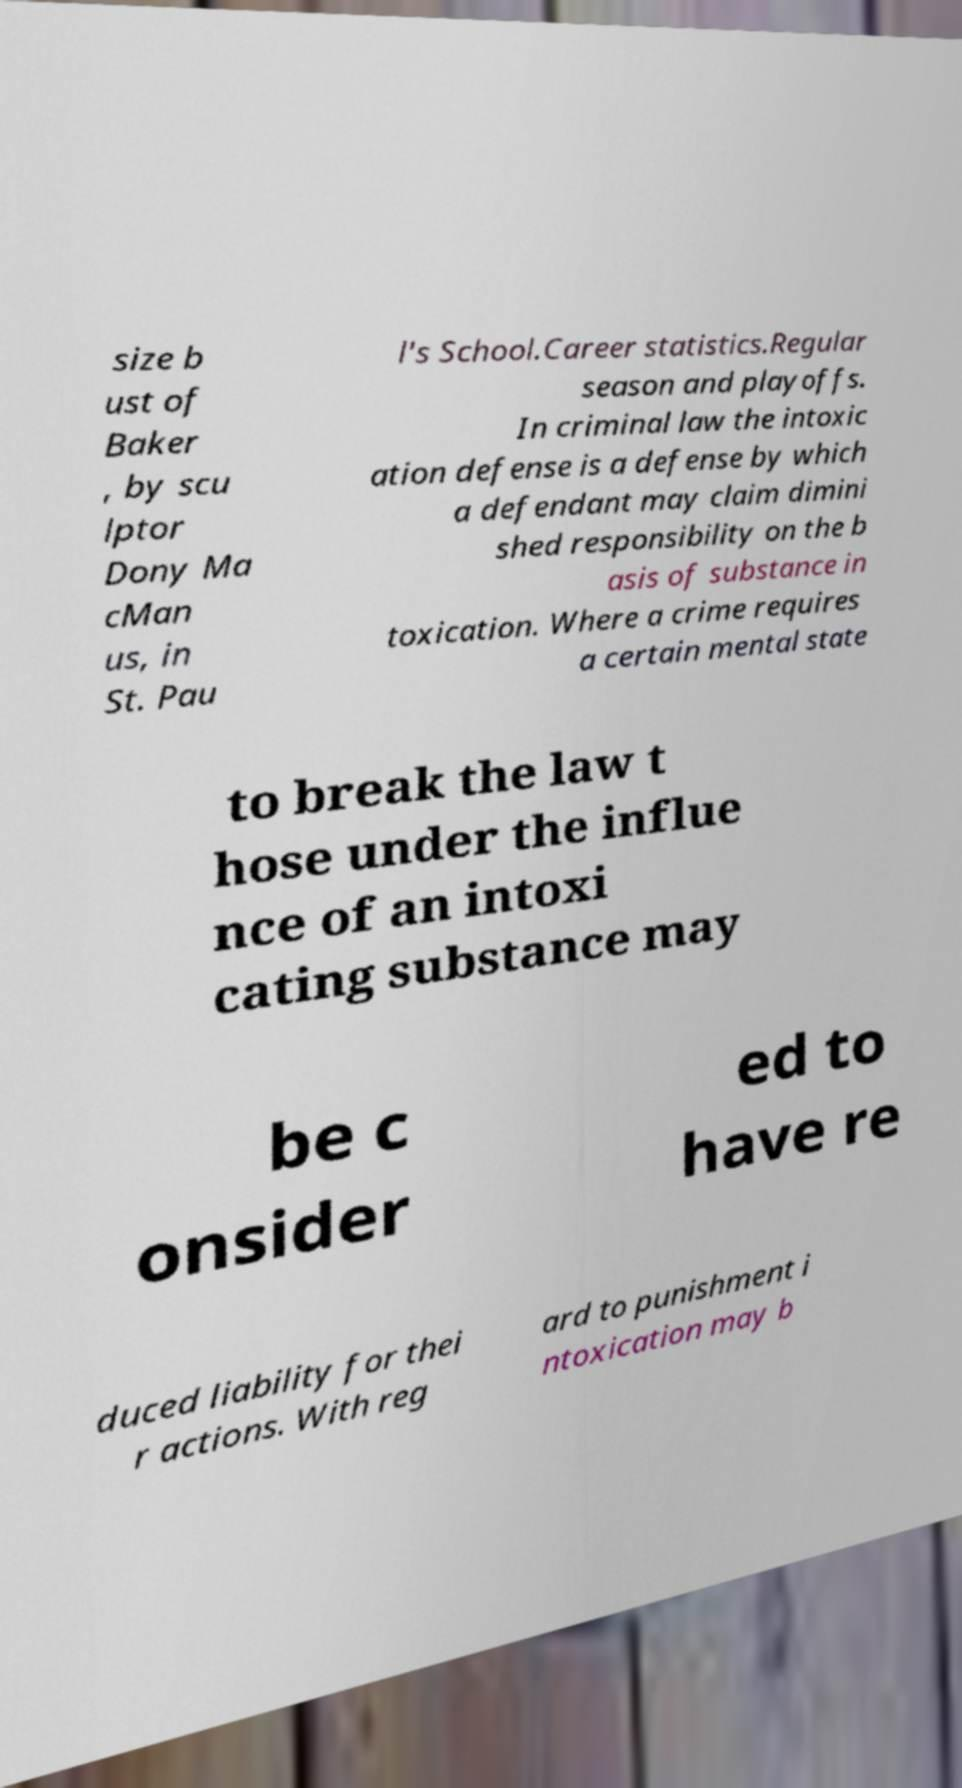I need the written content from this picture converted into text. Can you do that? size b ust of Baker , by scu lptor Dony Ma cMan us, in St. Pau l's School.Career statistics.Regular season and playoffs. In criminal law the intoxic ation defense is a defense by which a defendant may claim dimini shed responsibility on the b asis of substance in toxication. Where a crime requires a certain mental state to break the law t hose under the influe nce of an intoxi cating substance may be c onsider ed to have re duced liability for thei r actions. With reg ard to punishment i ntoxication may b 